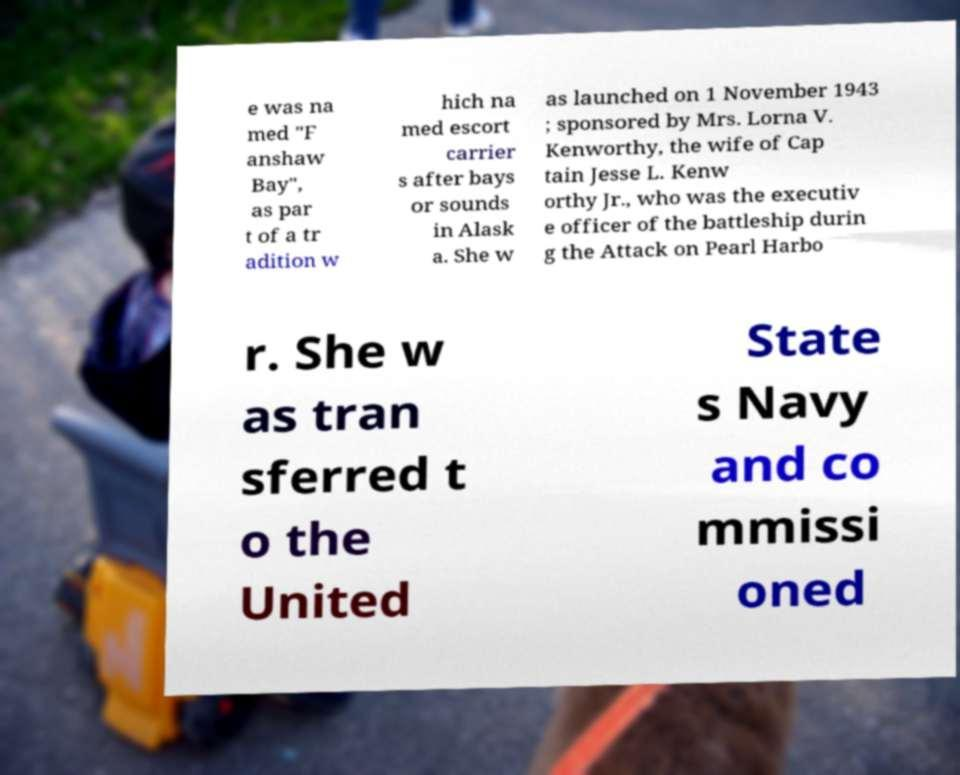Can you accurately transcribe the text from the provided image for me? e was na med "F anshaw Bay", as par t of a tr adition w hich na med escort carrier s after bays or sounds in Alask a. She w as launched on 1 November 1943 ; sponsored by Mrs. Lorna V. Kenworthy, the wife of Cap tain Jesse L. Kenw orthy Jr., who was the executiv e officer of the battleship durin g the Attack on Pearl Harbo r. She w as tran sferred t o the United State s Navy and co mmissi oned 